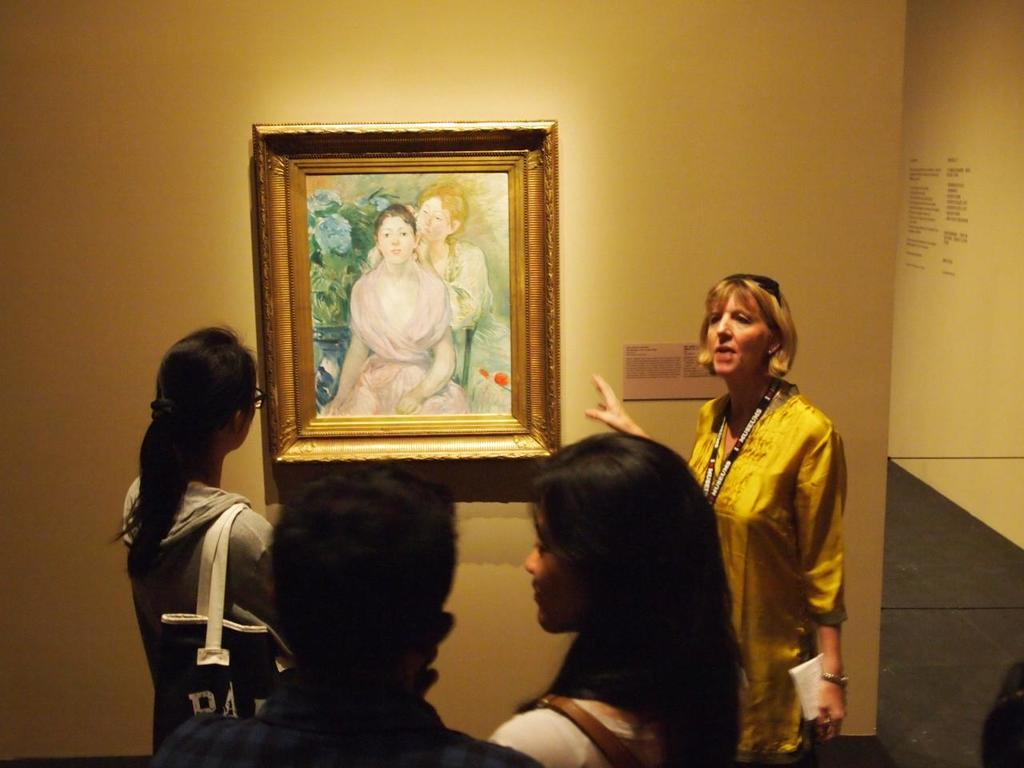What is on the wall in the image? There is a wall with a photograph in the image. What can be seen in the photograph? The photograph contains an image of a woman. Who is present near the wall? There is a woman standing near the wall. What is the woman doing near the wall? The woman is explaining something to other people. What is the subject of the woman's explanation? The subject of the explanation is the woman in the photograph. How many tomatoes are on the cherry tree in the image? There is no cherry tree or tomatoes present in the image. 